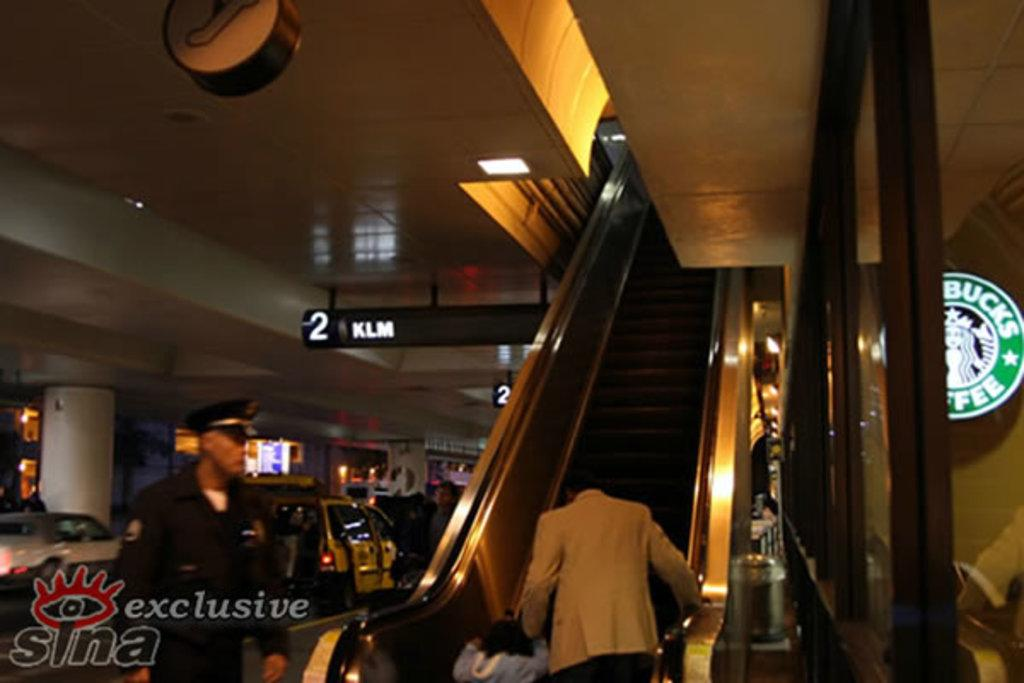Provide a one-sentence caption for the provided image. A black and white sign reads 2 KLM behind the escalator. 